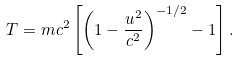<formula> <loc_0><loc_0><loc_500><loc_500>T = m c ^ { 2 } \left [ \left ( 1 - \frac { u ^ { 2 } } { c ^ { 2 } } \right ) ^ { - 1 / 2 } - 1 \right ] .</formula> 